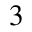<formula> <loc_0><loc_0><loc_500><loc_500>_ { 3 }</formula> 